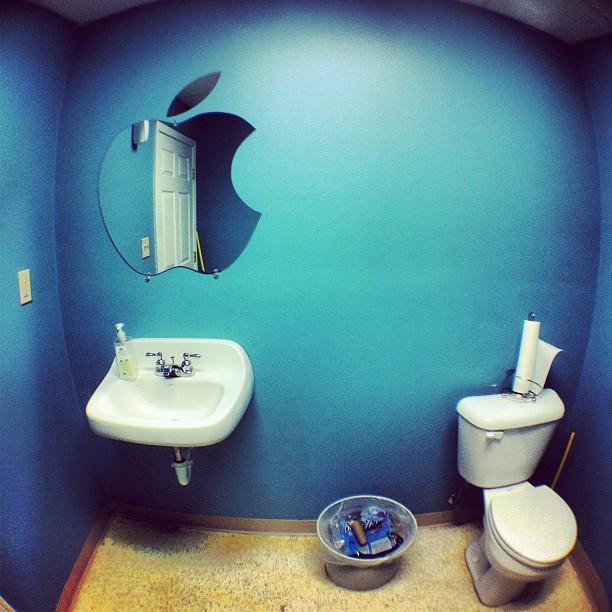How many folding chairs are in the picture?
Give a very brief answer. 0. 